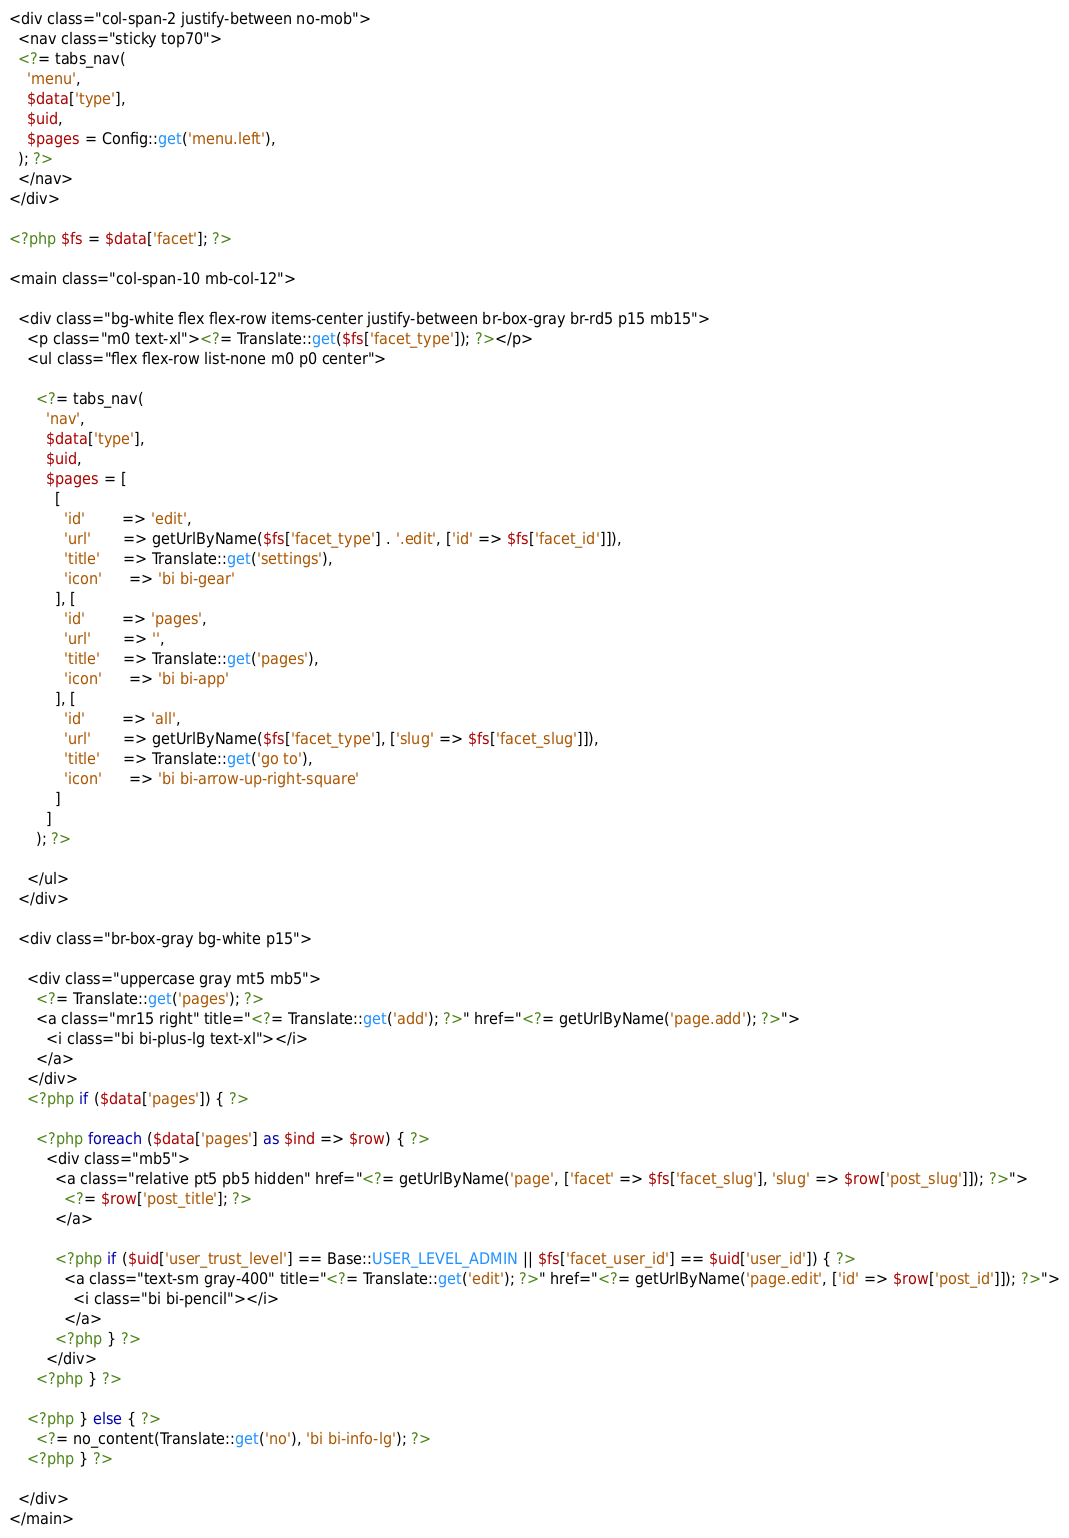Convert code to text. <code><loc_0><loc_0><loc_500><loc_500><_PHP_><div class="col-span-2 justify-between no-mob">
  <nav class="sticky top70">
  <?= tabs_nav(
    'menu',
    $data['type'],
    $uid,
    $pages = Config::get('menu.left'),
  ); ?>
  </nav>
</div>

<?php $fs = $data['facet']; ?>

<main class="col-span-10 mb-col-12">

  <div class="bg-white flex flex-row items-center justify-between br-box-gray br-rd5 p15 mb15">
    <p class="m0 text-xl"><?= Translate::get($fs['facet_type']); ?></p>
    <ul class="flex flex-row list-none m0 p0 center">

      <?= tabs_nav(
        'nav',
        $data['type'],
        $uid,
        $pages = [
          [
            'id'        => 'edit',
            'url'       => getUrlByName($fs['facet_type'] . '.edit', ['id' => $fs['facet_id']]),
            'title'     => Translate::get('settings'),
            'icon'      => 'bi bi-gear'
          ], [
            'id'        => 'pages',
            'url'       => '',
            'title'     => Translate::get('pages'),
            'icon'      => 'bi bi-app'
          ], [
            'id'        => 'all',
            'url'       => getUrlByName($fs['facet_type'], ['slug' => $fs['facet_slug']]),
            'title'     => Translate::get('go to'),
            'icon'      => 'bi bi-arrow-up-right-square'
          ]
        ]
      ); ?>

    </ul>
  </div>

  <div class="br-box-gray bg-white p15">

    <div class="uppercase gray mt5 mb5">
      <?= Translate::get('pages'); ?>
      <a class="mr15 right" title="<?= Translate::get('add'); ?>" href="<?= getUrlByName('page.add'); ?>">
        <i class="bi bi-plus-lg text-xl"></i>
      </a>
    </div>
    <?php if ($data['pages']) { ?>

      <?php foreach ($data['pages'] as $ind => $row) { ?>
        <div class="mb5">
          <a class="relative pt5 pb5 hidden" href="<?= getUrlByName('page', ['facet' => $fs['facet_slug'], 'slug' => $row['post_slug']]); ?>">
            <?= $row['post_title']; ?>
          </a>

          <?php if ($uid['user_trust_level'] == Base::USER_LEVEL_ADMIN || $fs['facet_user_id'] == $uid['user_id']) { ?>
            <a class="text-sm gray-400" title="<?= Translate::get('edit'); ?>" href="<?= getUrlByName('page.edit', ['id' => $row['post_id']]); ?>">
              <i class="bi bi-pencil"></i>
            </a>
          <?php } ?>
        </div>
      <?php } ?>

    <?php } else { ?>
      <?= no_content(Translate::get('no'), 'bi bi-info-lg'); ?>
    <?php } ?>

  </div>
</main></code> 